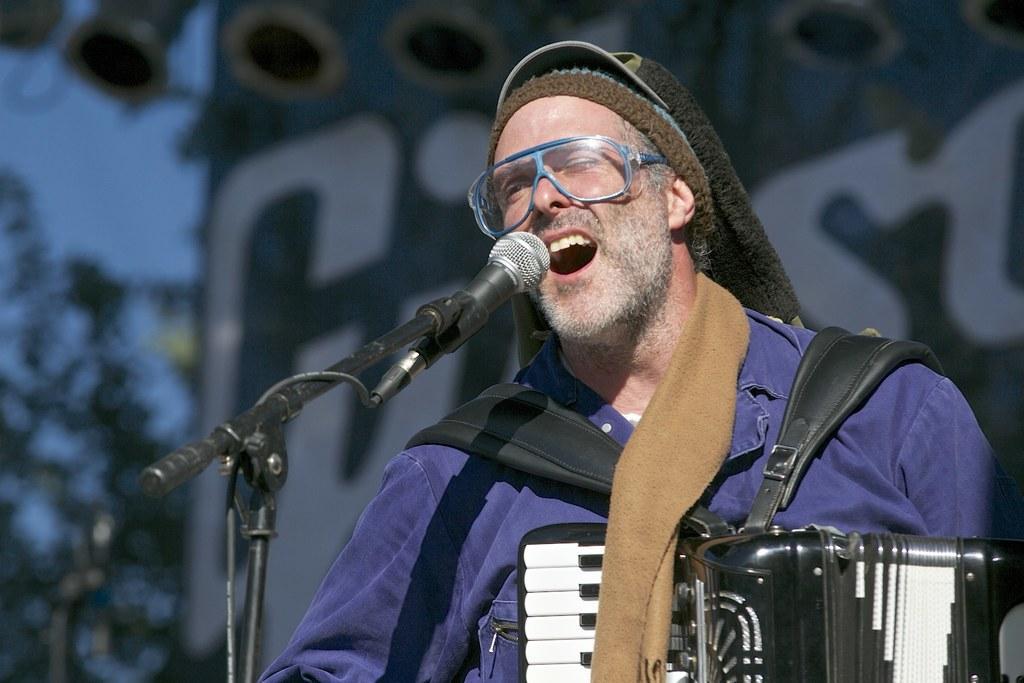Please provide a concise description of this image. In the image I can see a person wearing cap and playing the musical instrument in front of the mic and to the side there is a tree. 